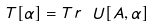Convert formula to latex. <formula><loc_0><loc_0><loc_500><loc_500>T [ \alpha ] = T r \ U [ A , \alpha ]</formula> 